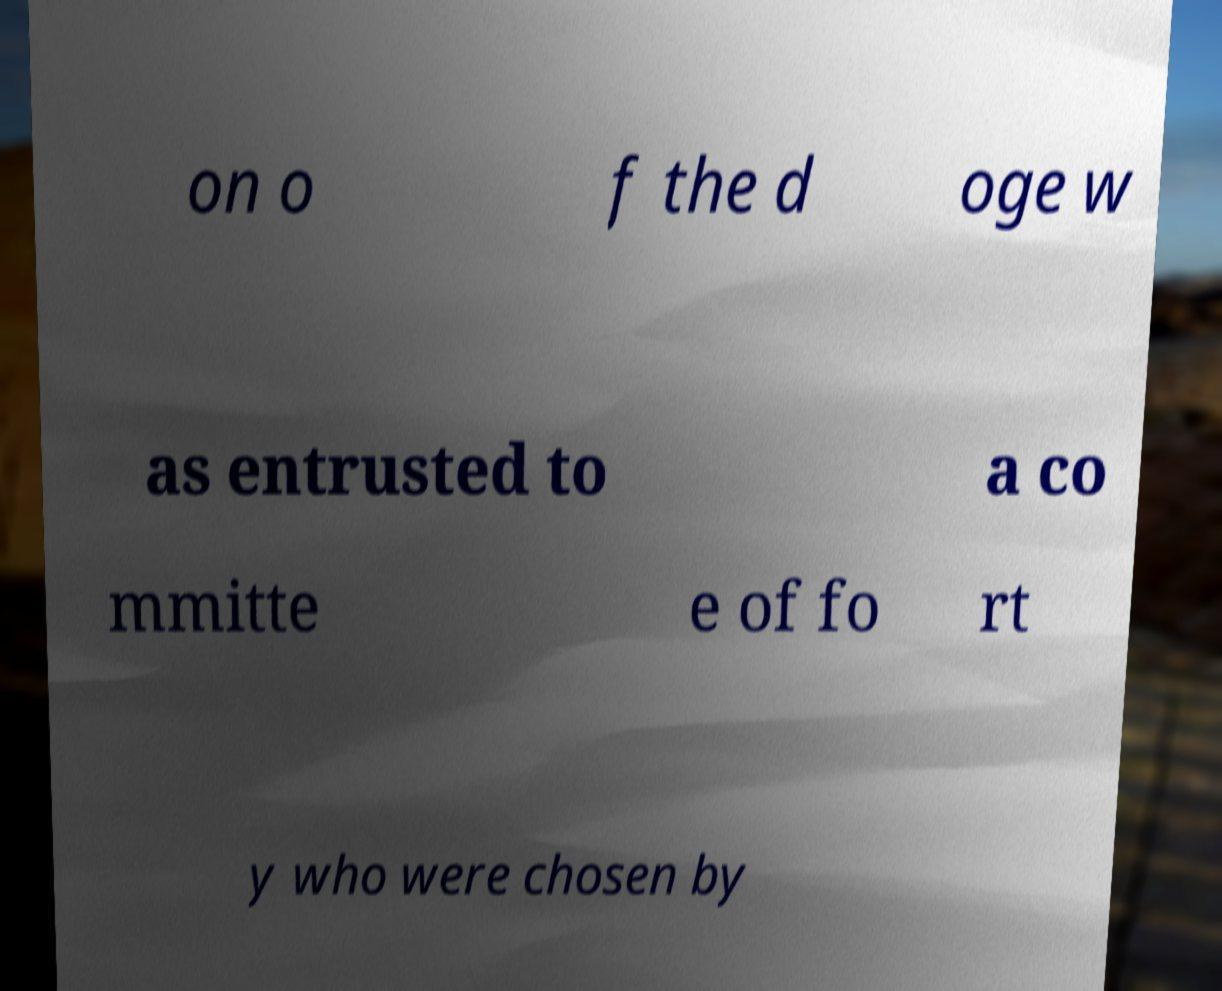I need the written content from this picture converted into text. Can you do that? on o f the d oge w as entrusted to a co mmitte e of fo rt y who were chosen by 